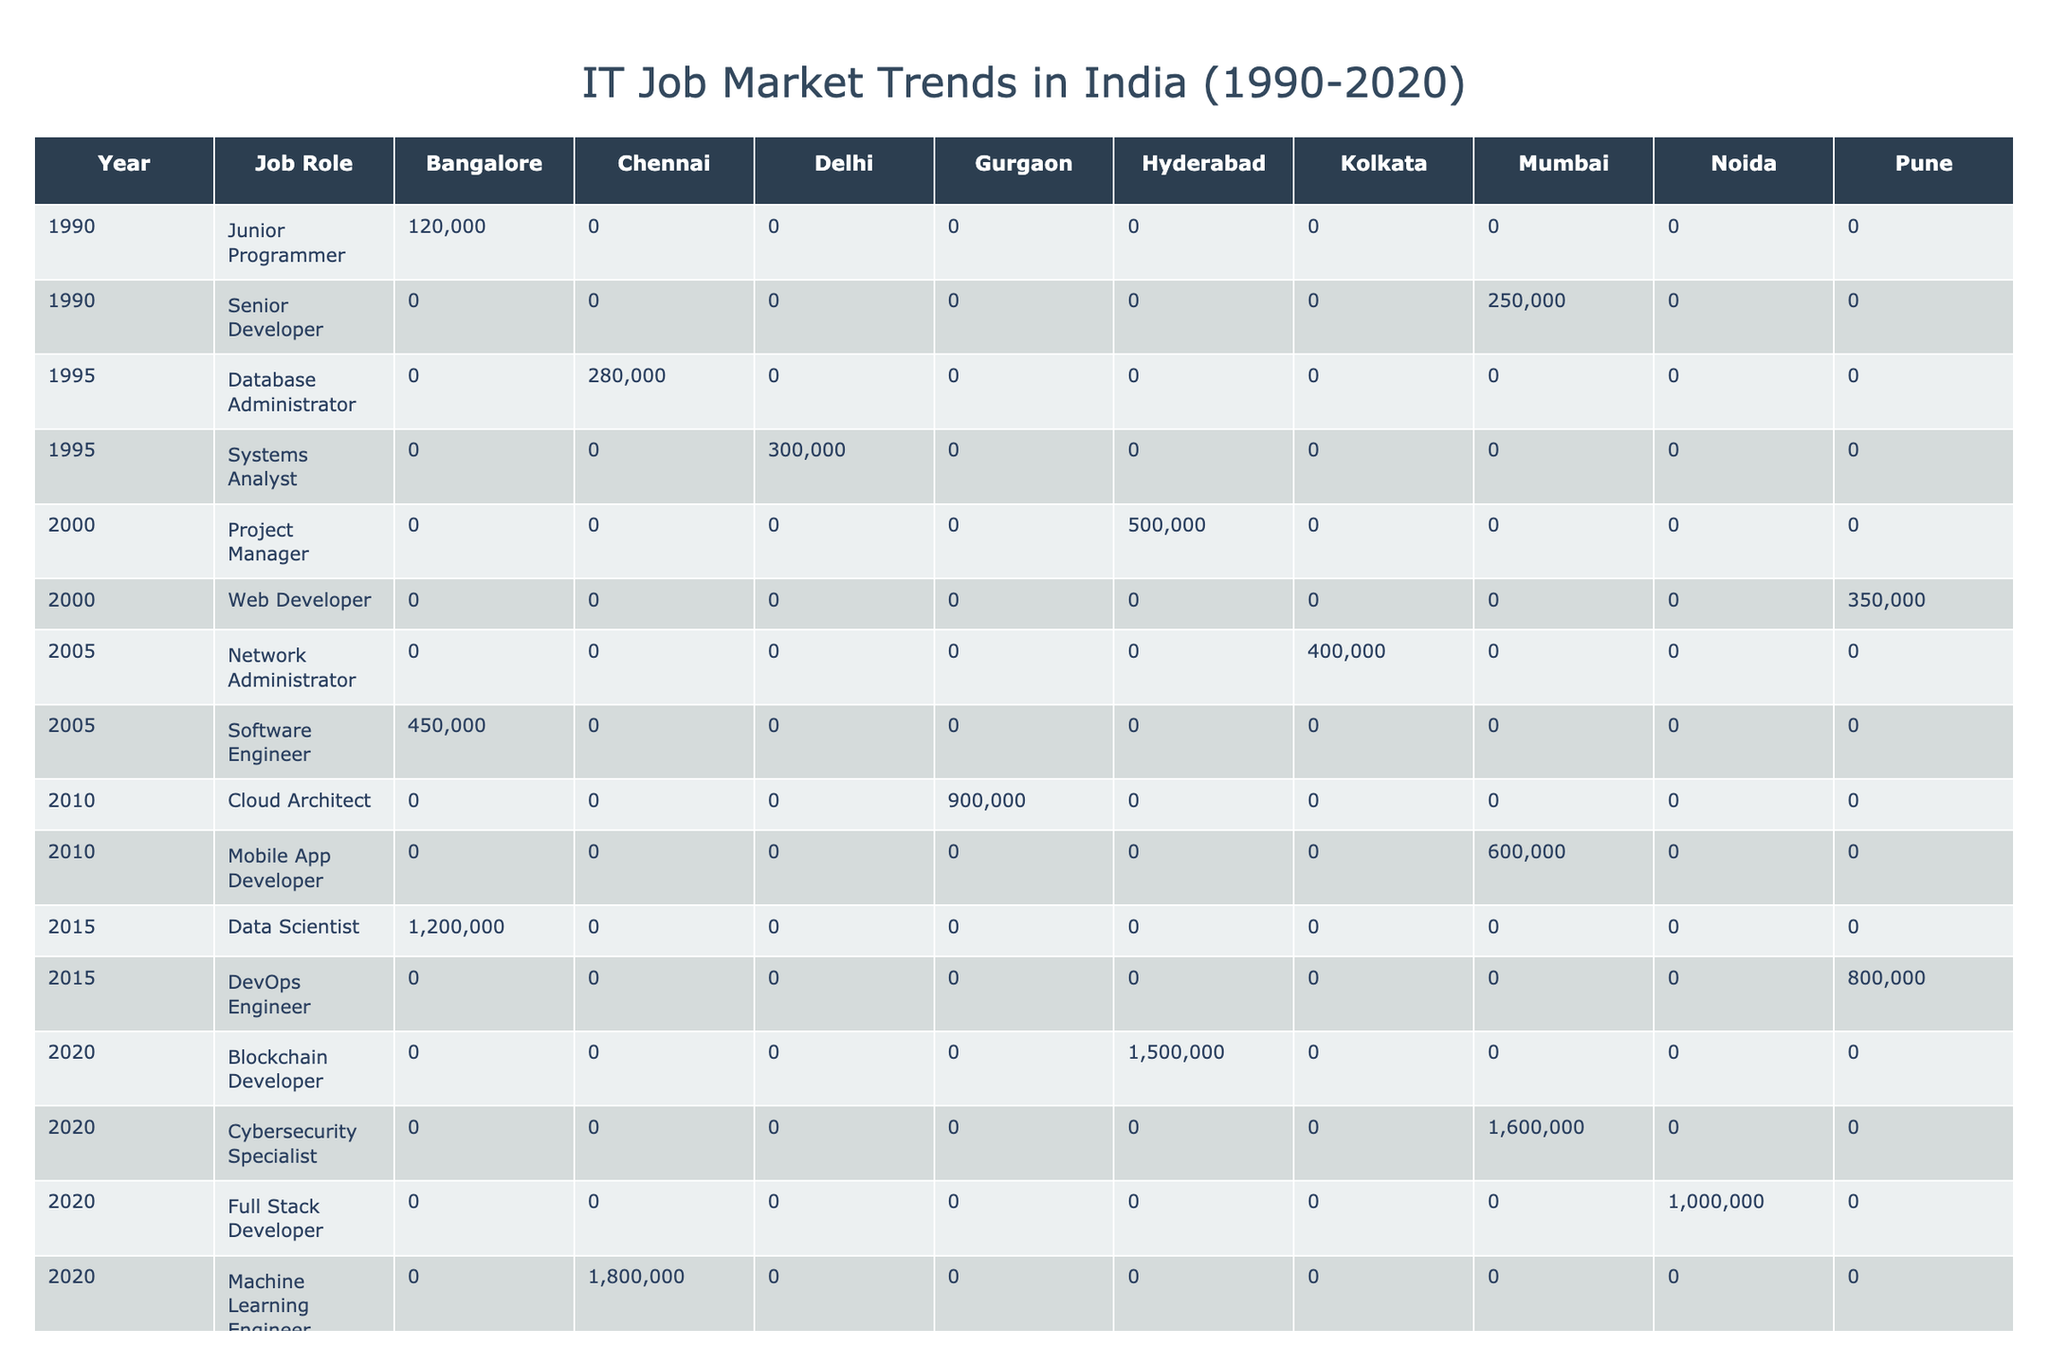What is the highest salary recorded for a job role in Bangalore? The table shows that the highest salary for a job role in Bangalore is for the Data Scientist position in 2015, which is 1,200,000 INR.
Answer: 1,200,000 INR Which job role had the lowest average salary across all cities in 1990? The table shows the salaries for different job roles in 1990: Junior Programmer (120,000 INR) and Senior Developer (250,000 INR). The Junior Programmer has the lowest salary at 120,000 INR.
Answer: Junior Programmer How many different job roles were listed for the year 2020? The table has a total of 4 different job roles listed for the year 2020: Blockchain Developer, Machine Learning Engineer, Full Stack Developer, and Cybersecurity Specialist.
Answer: 4 What is the average salary for Senior Developer and Project Manager roles from 1990 to 2000? For Senior Developer (1990: 250,000 INR) and Project Manager (2000: 500,000 INR), their average salary is calculated as (250,000 + 500,000) / 2 = 375,000 INR.
Answer: 375,000 INR Is it true that the Machine Learning Engineer had a higher salary than the Cybersecurity Specialist in 2020? In 2020, the Machine Learning Engineer had a salary of 1,800,000 INR, while the Cybersecurity Specialist had a salary of 1,600,000 INR, so it is true that Machine Learning Engineer had a higher salary.
Answer: Yes What was the salary difference between the highest and lowest paying job roles in 2015? In 2015, the Data Scientist had the highest salary of 1,200,000 INR, and the DevOps Engineer had a salary of 800,000 INR. The difference is 1,200,000 - 800,000 = 400,000 INR.
Answer: 400,000 INR Which city had the highest average salary for IT job roles in the year 2020? Based on the 2020 data, the highest salaries were for Cybersecurity Specialist (1,600,000 INR, Mumbai) and Machine Learning Engineer (1,800,000 INR, Chennai); hence, Chennai has the highest average salary.
Answer: Chennai What is the total salary paid to Network Administrator and Mobile App Developer across their respective years? For Network Administrator (2005: 400,000 INR) and Mobile App Developer (2010: 600,000 INR), the total salary is 400,000 + 600,000 = 1,000,000 INR.
Answer: 1,000,000 INR How many years of experience did the Web Developer and Database Administrator have combined? The Web Developer (2000) had 2 years of experience, while the Database Administrator (1995) had 4 years. Therefore, the combined experience is 2 + 4 = 6 years.
Answer: 6 years 